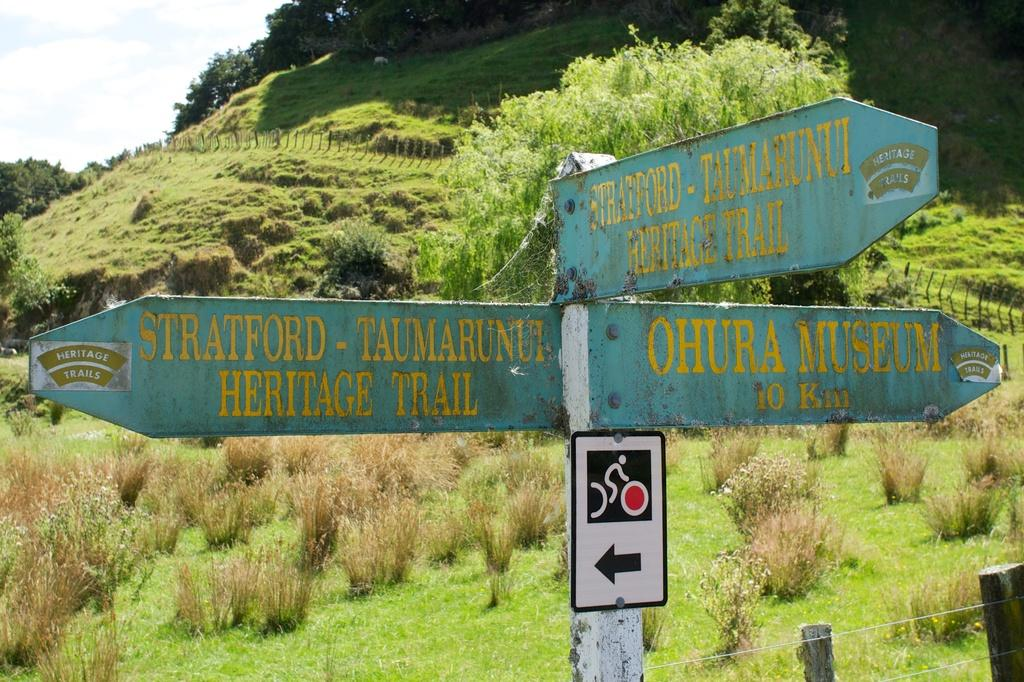Provide a one-sentence caption for the provided image. A road sign in a grassy area that points the directions to a museum, and two different trails. 